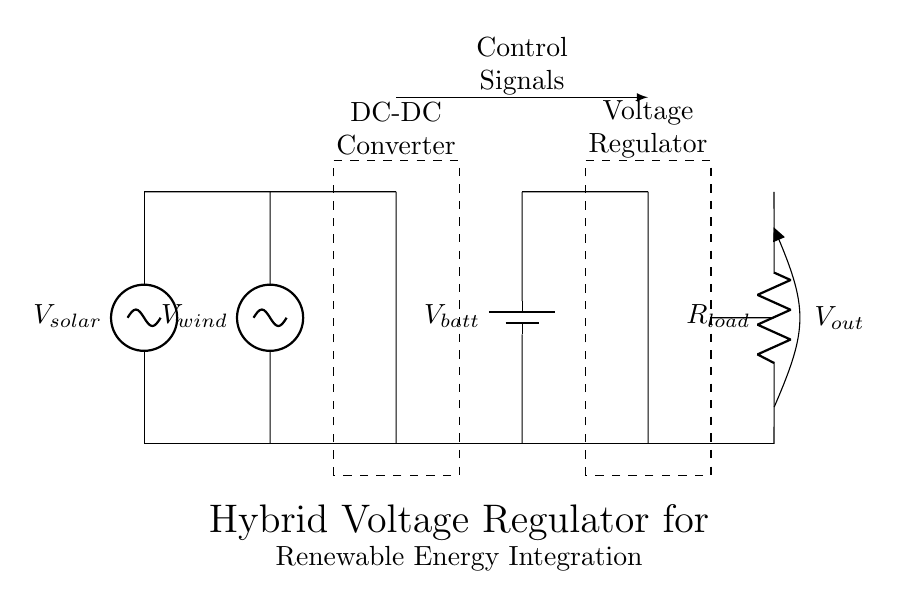What is the source voltage from the solar panel? The source voltage from the solar panel is labeled as V_solar, indicated at the left side of the diagram.
Answer: V_solar What component connects the wind turbine to the circuit? The wind turbine is connected using a voltage source labeled V_wind, directly to the circuit on the left side just like the solar panel.
Answer: V_wind What is the purpose of the DC-DC converter in this circuit? The DC-DC converter adjusts the voltage levels from sources like the solar panel and wind turbine to match the requirements of the battery and load, ensuring stable output.
Answer: Voltage adjustment What is the output voltage labeled as? The output voltage is indicated as V_out, located at the right end of the circuit diagram connected to the load resistor.
Answer: V_out How many energy sources are integrated in this hybrid voltage regulator? There are two energy sources integrated into the hybrid regulator: one from the solar panel and another from the wind turbine, contributing to overall energy.
Answer: Two What does the dashed rectangle represent about the voltage regulator? The dashed rectangle represents the voltage regulator itself, indicating its discrete nature within the circuit and its role in managing output voltage.
Answer: Voltage Regulator What is the load connected to in the circuit? The load is connected to a resistor labeled R_load, which receives the output voltage V_out generated by the voltage regulator.
Answer: R_load 